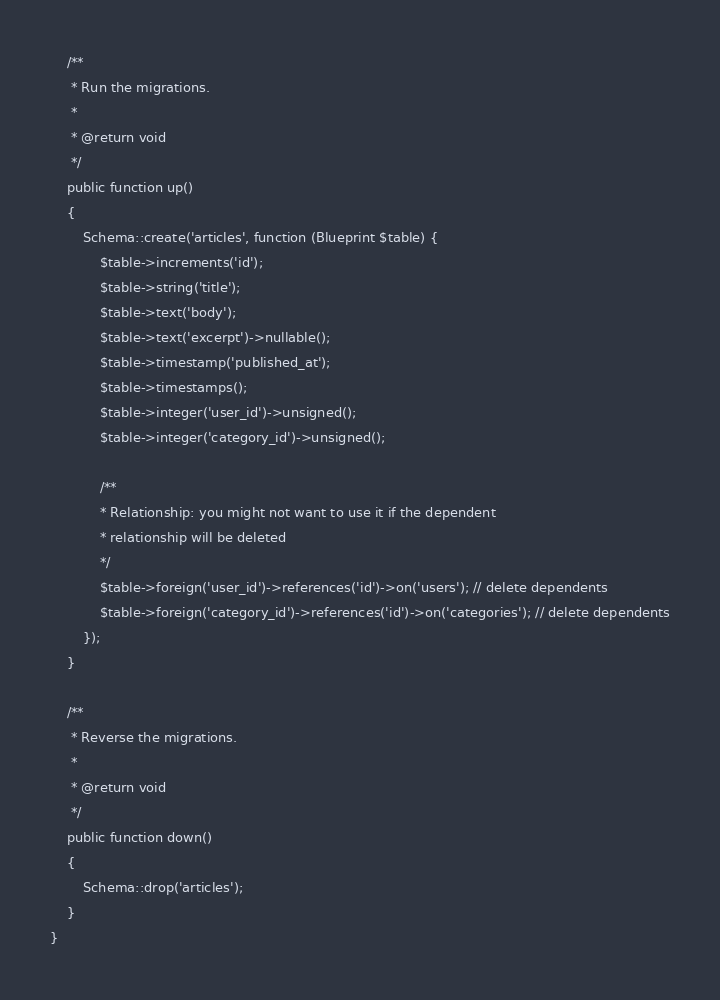Convert code to text. <code><loc_0><loc_0><loc_500><loc_500><_PHP_>    /**
     * Run the migrations.
     *
     * @return void
     */
    public function up()
    {
        Schema::create('articles', function (Blueprint $table) {
            $table->increments('id');
            $table->string('title');
            $table->text('body');
            $table->text('excerpt')->nullable();
            $table->timestamp('published_at');
            $table->timestamps();
            $table->integer('user_id')->unsigned();
            $table->integer('category_id')->unsigned();

            /**
            * Relationship: you might not want to use it if the dependent
            * relationship will be deleted
            */
            $table->foreign('user_id')->references('id')->on('users'); // delete dependents
            $table->foreign('category_id')->references('id')->on('categories'); // delete dependents
        });
    }

    /**
     * Reverse the migrations.
     *
     * @return void
     */
    public function down()
    {
        Schema::drop('articles');
    }
}
</code> 